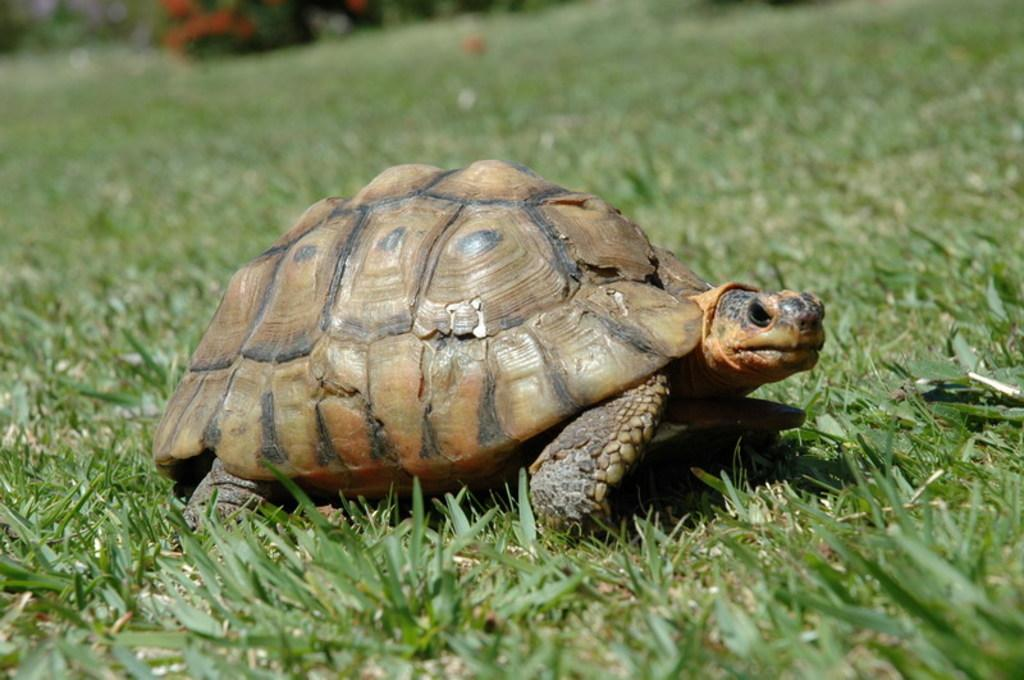What animal is present in the image? There is a tortoise in the image. Where is the tortoise located? The tortoise is on the grass. What else can be seen in the image besides the tortoise? There are plants in the image. Can you describe the background of the image? The background of the image is blurred. What type of pain is the tortoise experiencing in the image? There is no indication of pain in the image; the tortoise appears to be on the grass without any visible signs of distress. 